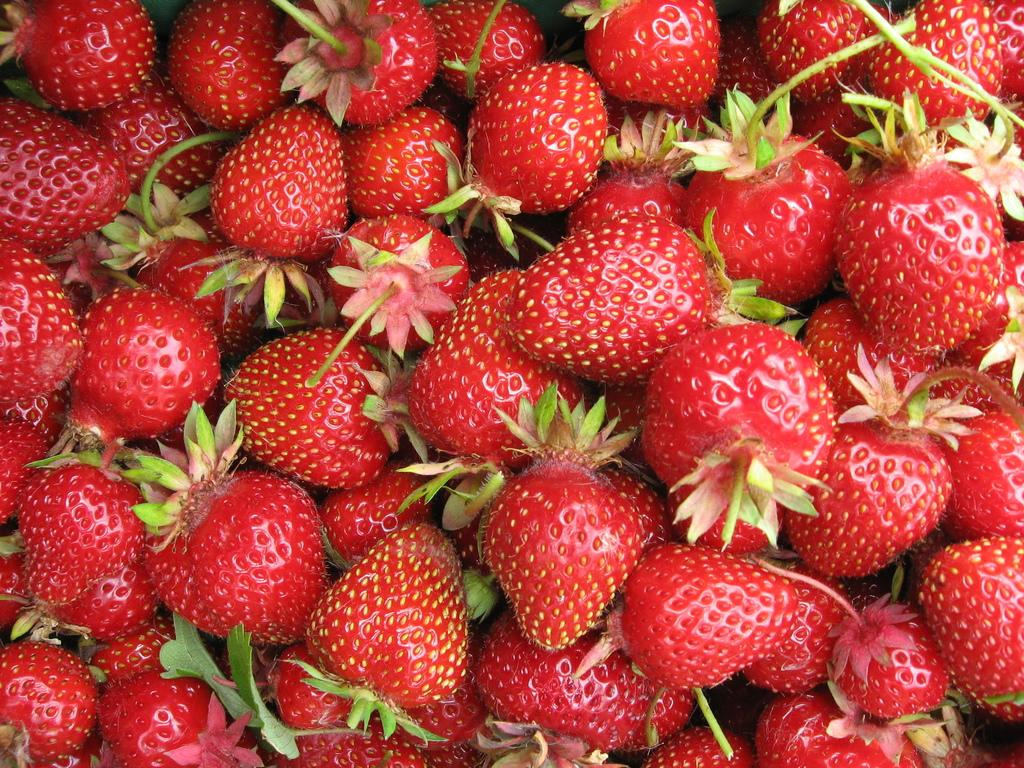What type of fruit is featured in the image? There are many strawberries in the image. What color are the strawberries? The strawberries are red in color. How many cells are in the jail depicted in the image? There is no jail present in the image; it features many strawberries. What type of transportation is shown in the image? There is no transportation, such as a train, present in the image. 